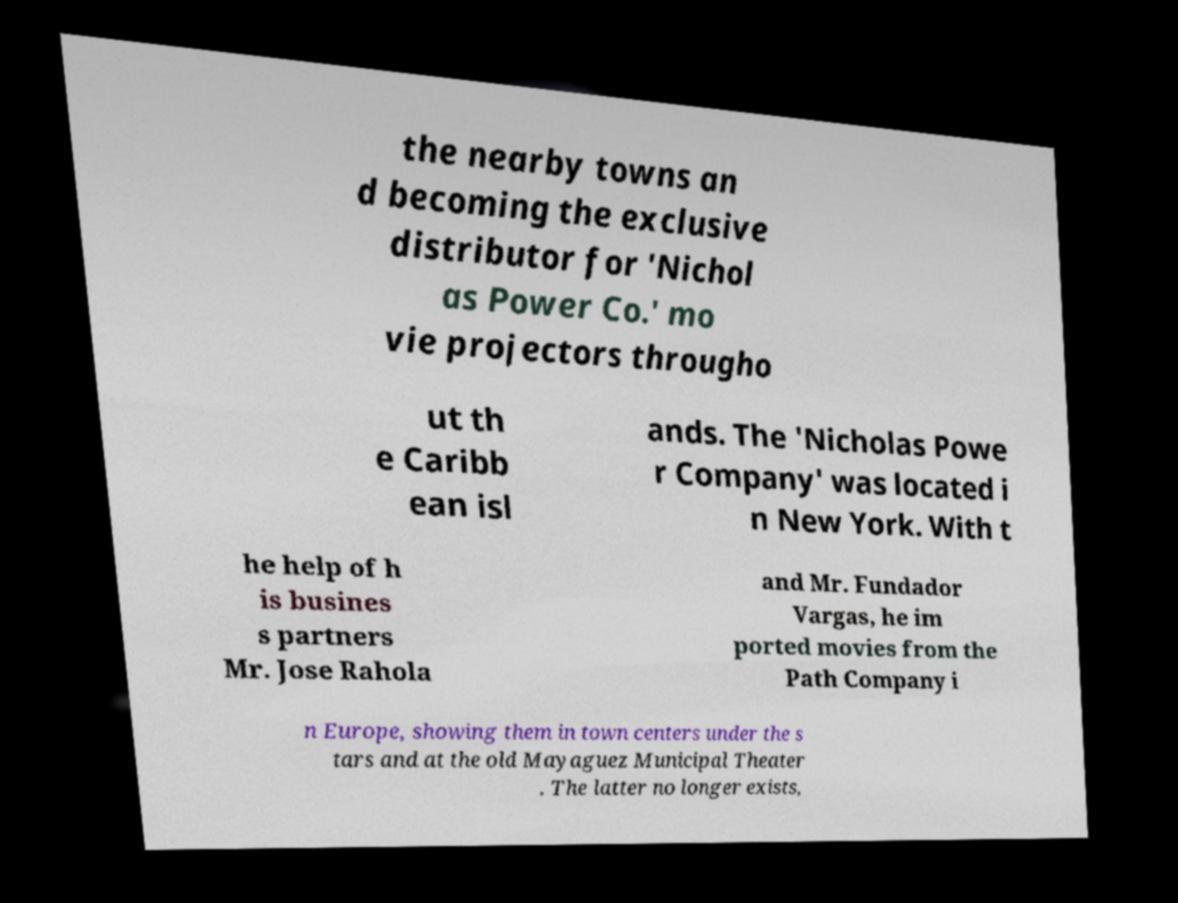Please identify and transcribe the text found in this image. the nearby towns an d becoming the exclusive distributor for 'Nichol as Power Co.' mo vie projectors througho ut th e Caribb ean isl ands. The 'Nicholas Powe r Company' was located i n New York. With t he help of h is busines s partners Mr. Jose Rahola and Mr. Fundador Vargas, he im ported movies from the Path Company i n Europe, showing them in town centers under the s tars and at the old Mayaguez Municipal Theater . The latter no longer exists, 